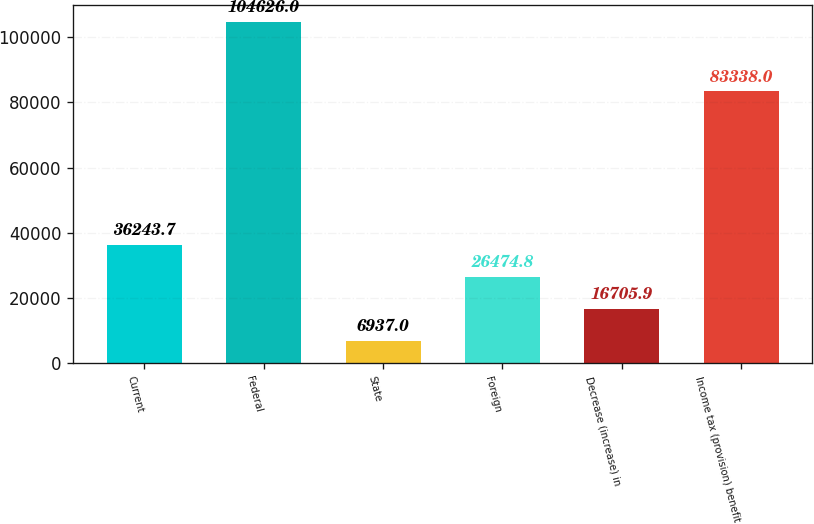<chart> <loc_0><loc_0><loc_500><loc_500><bar_chart><fcel>Current<fcel>Federal<fcel>State<fcel>Foreign<fcel>Decrease (increase) in<fcel>Income tax (provision) benefit<nl><fcel>36243.7<fcel>104626<fcel>6937<fcel>26474.8<fcel>16705.9<fcel>83338<nl></chart> 